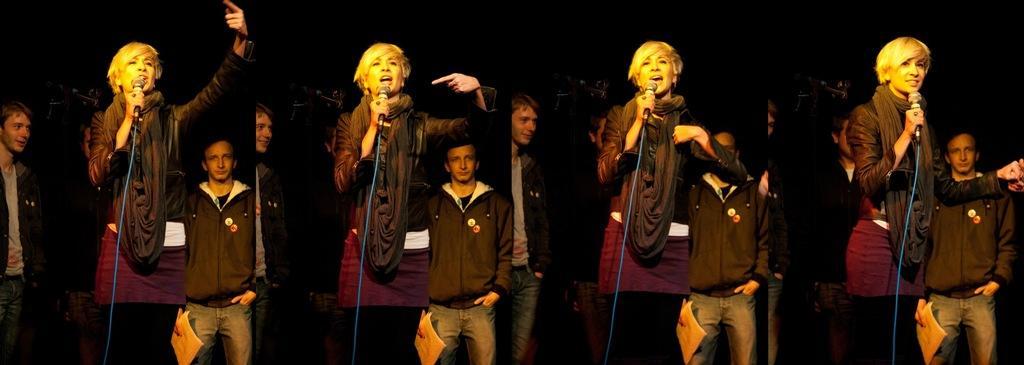In one or two sentences, can you explain what this image depicts? In the picture we can see four images which are same and in the first image we can see a woman standing and singing a song in the microphone holding it and beside her we can see a man standing, and behind her also we can see a man standing and in the second image we can see a woman showing her hand towards her and in the third image we can see the woman showing herself with a hand and in the fourth image we can see the woman turning to right. 